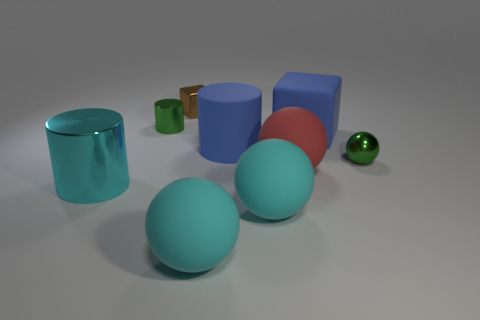Subtract all yellow spheres. Subtract all purple cylinders. How many spheres are left? 4 Subtract all blocks. How many objects are left? 7 Add 1 red spheres. How many red spheres exist? 2 Subtract 0 gray cylinders. How many objects are left? 9 Subtract all red rubber spheres. Subtract all cyan cylinders. How many objects are left? 7 Add 1 large blue matte blocks. How many large blue matte blocks are left? 2 